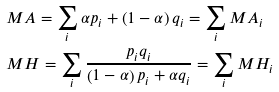Convert formula to latex. <formula><loc_0><loc_0><loc_500><loc_500>& M A = \sum _ { i } \alpha p _ { i } + \left ( 1 - \alpha \right ) q _ { i } = \sum _ { i } M A _ { i } \\ & M H = \sum _ { i } \frac { p _ { i } q _ { i } } { \left ( 1 - \alpha \right ) p _ { i } + \alpha q _ { i } } = \sum _ { i } M H _ { i }</formula> 